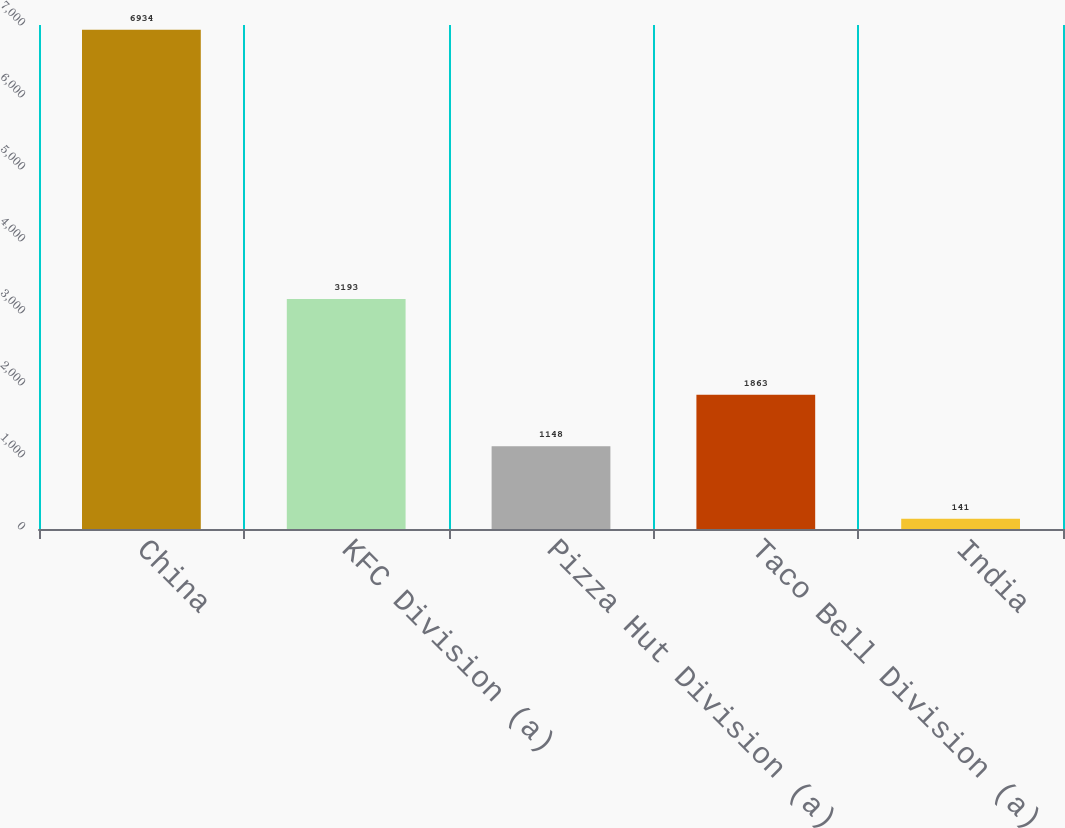<chart> <loc_0><loc_0><loc_500><loc_500><bar_chart><fcel>China<fcel>KFC Division (a)<fcel>Pizza Hut Division (a)<fcel>Taco Bell Division (a)<fcel>India<nl><fcel>6934<fcel>3193<fcel>1148<fcel>1863<fcel>141<nl></chart> 